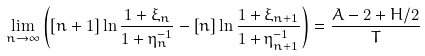<formula> <loc_0><loc_0><loc_500><loc_500>\lim _ { n \rightarrow \infty } \left ( \left [ n + 1 \right ] \ln \frac { 1 + \xi _ { n } } { 1 + \eta _ { n } ^ { - 1 } } - \left [ n \right ] \ln \frac { 1 + \xi _ { n + 1 } } { 1 + \eta _ { n + 1 } ^ { - 1 } } \right ) = \frac { A - 2 + H / 2 } T</formula> 